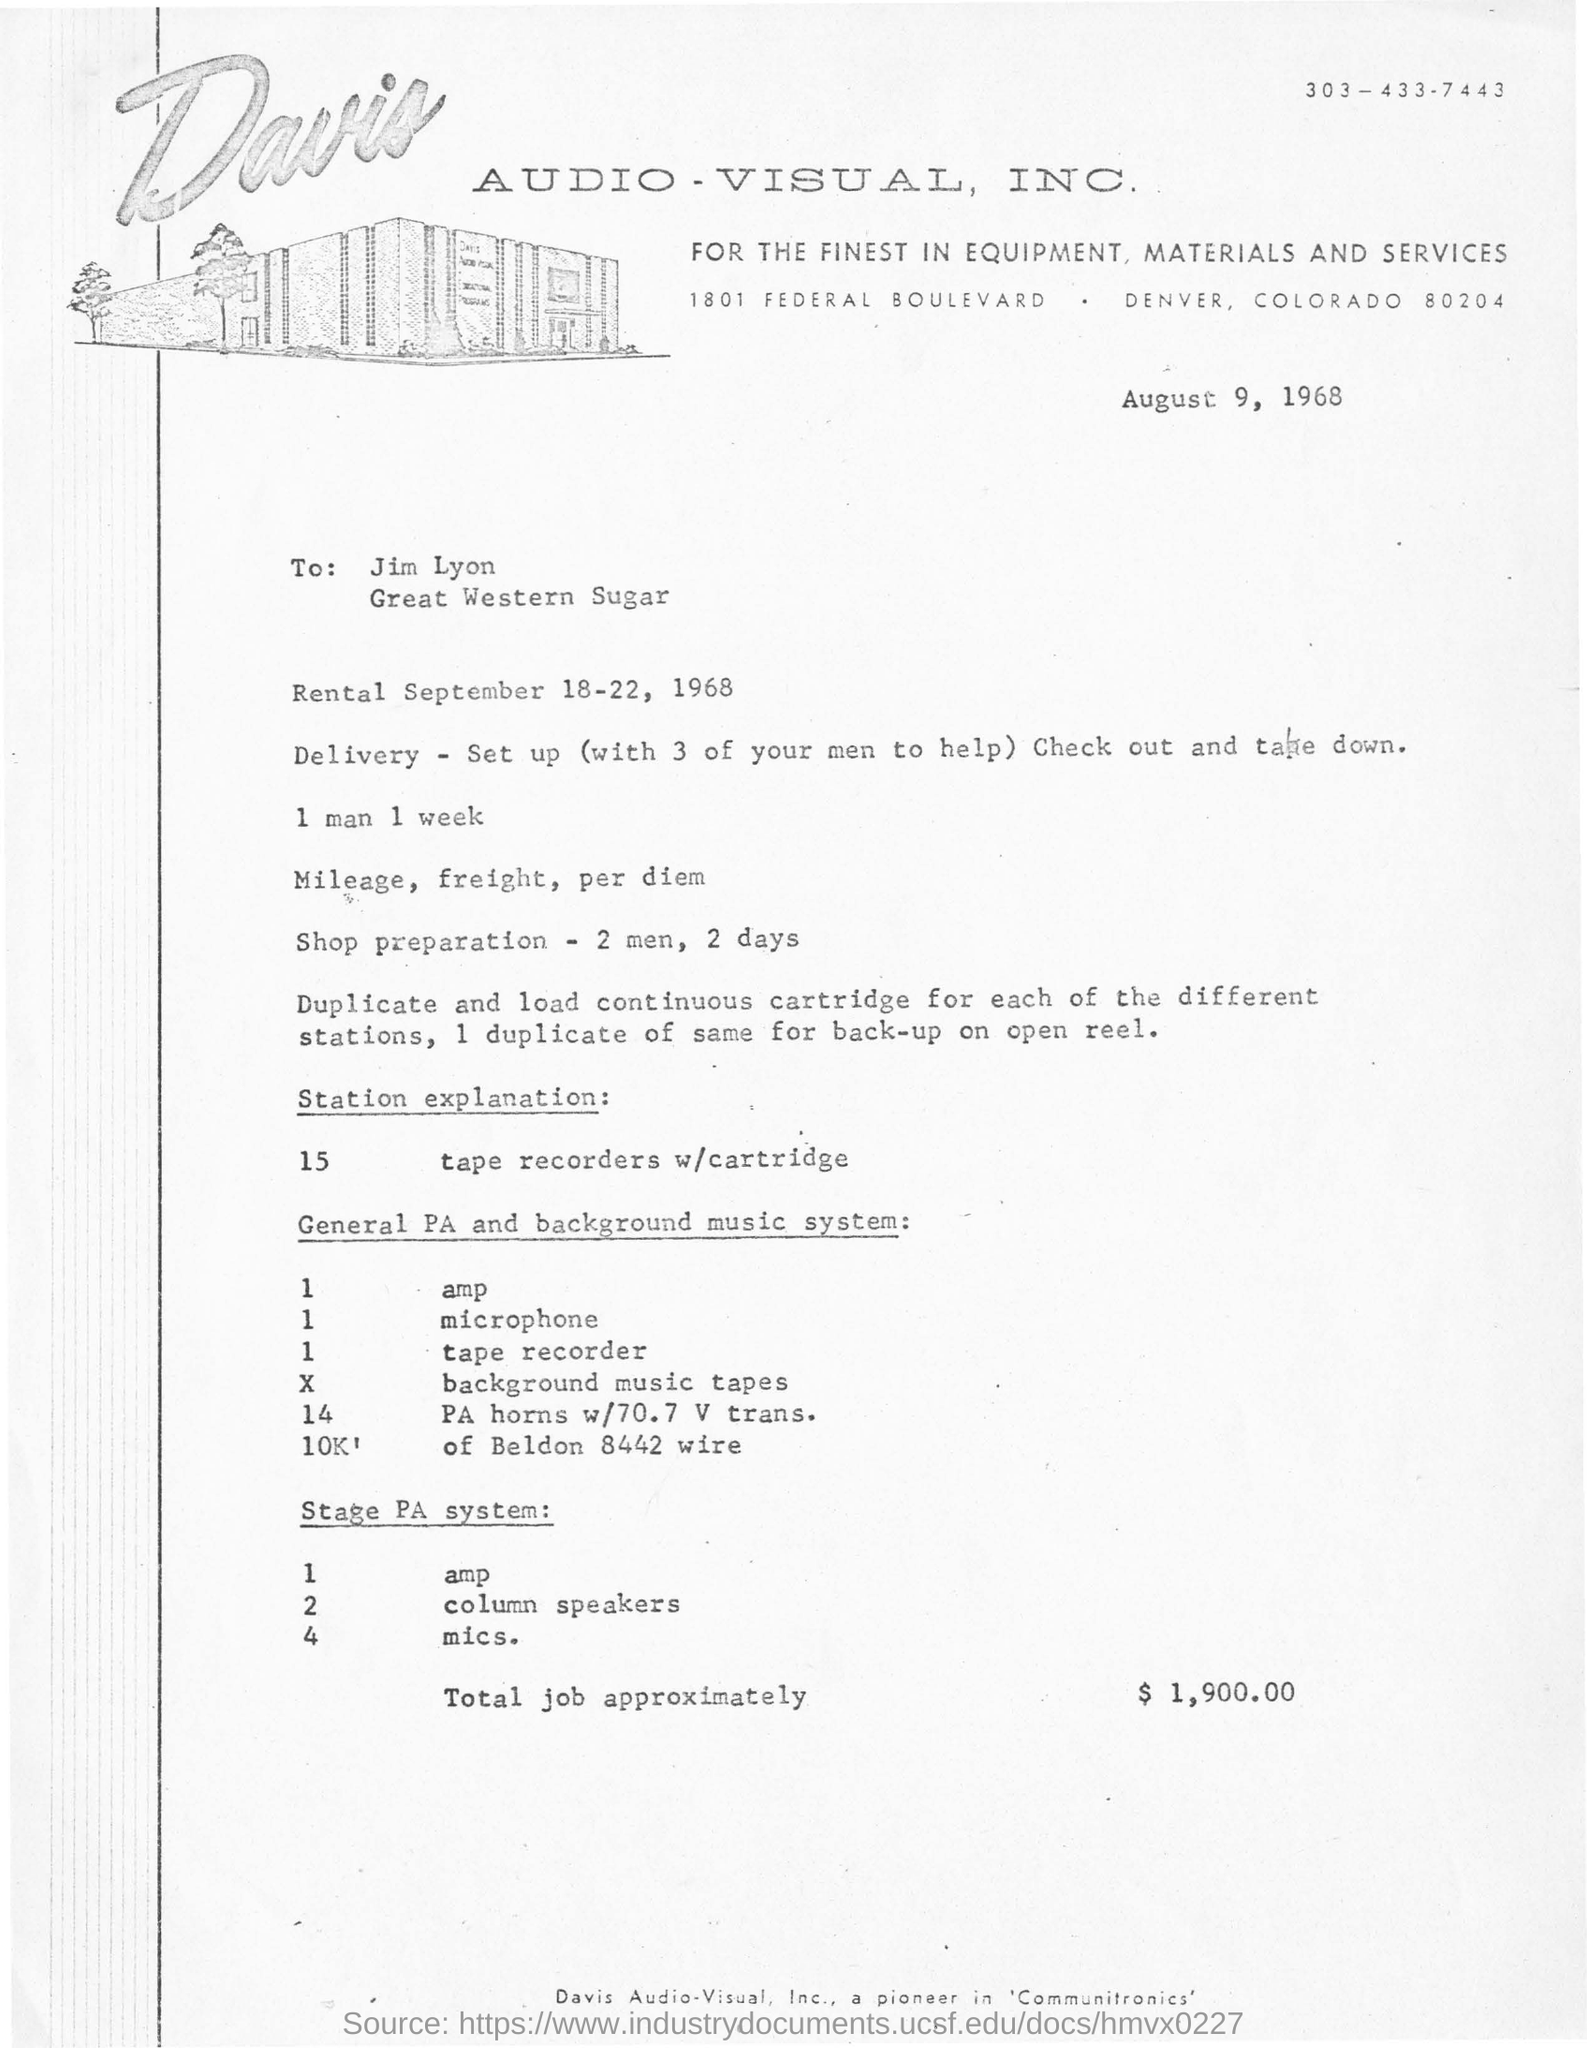To whom this letter was written ?
Provide a succinct answer. Jim lyon. What is the value of total job approximately ?
Provide a short and direct response. $ 1,900.00. What does station explanation consists of?
Provide a succinct answer. 15 tape recorders w/cartridge. 